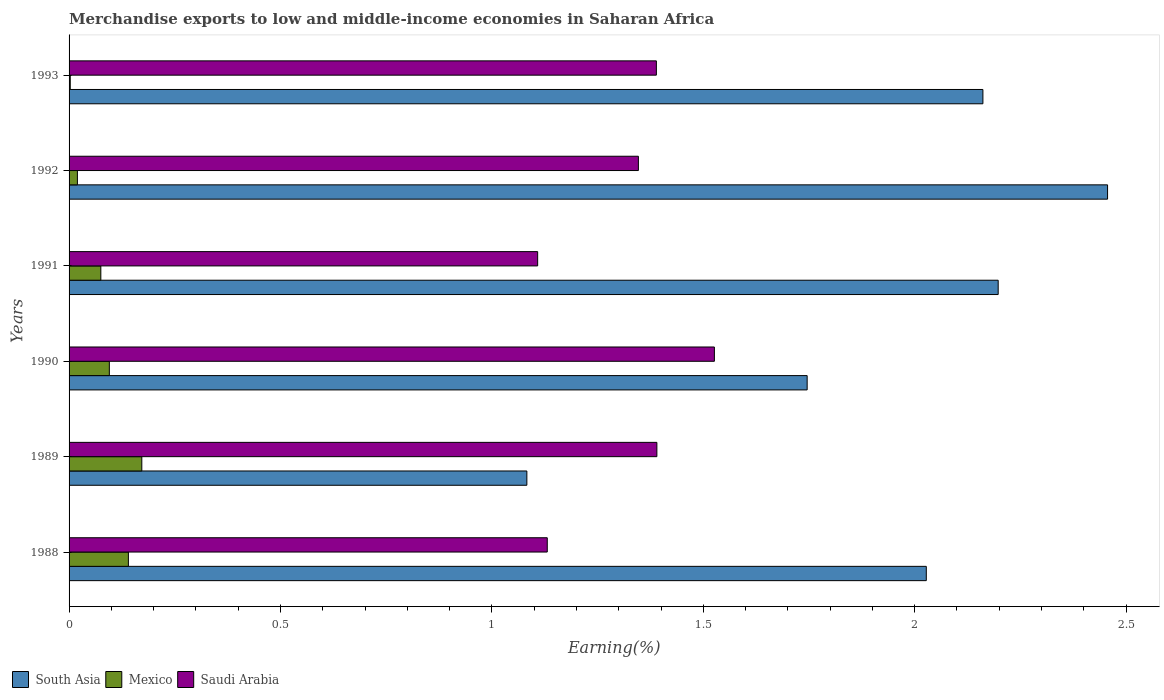How many different coloured bars are there?
Your response must be concise. 3. How many groups of bars are there?
Provide a short and direct response. 6. What is the label of the 3rd group of bars from the top?
Give a very brief answer. 1991. In how many cases, is the number of bars for a given year not equal to the number of legend labels?
Your answer should be very brief. 0. What is the percentage of amount earned from merchandise exports in Saudi Arabia in 1989?
Offer a very short reply. 1.39. Across all years, what is the maximum percentage of amount earned from merchandise exports in Mexico?
Provide a short and direct response. 0.17. Across all years, what is the minimum percentage of amount earned from merchandise exports in South Asia?
Your response must be concise. 1.08. What is the total percentage of amount earned from merchandise exports in Mexico in the graph?
Ensure brevity in your answer.  0.51. What is the difference between the percentage of amount earned from merchandise exports in South Asia in 1988 and that in 1991?
Your response must be concise. -0.17. What is the difference between the percentage of amount earned from merchandise exports in Saudi Arabia in 1993 and the percentage of amount earned from merchandise exports in Mexico in 1988?
Your answer should be compact. 1.25. What is the average percentage of amount earned from merchandise exports in South Asia per year?
Ensure brevity in your answer.  1.95. In the year 1990, what is the difference between the percentage of amount earned from merchandise exports in Mexico and percentage of amount earned from merchandise exports in Saudi Arabia?
Your answer should be compact. -1.43. In how many years, is the percentage of amount earned from merchandise exports in Saudi Arabia greater than 2.2 %?
Provide a short and direct response. 0. What is the ratio of the percentage of amount earned from merchandise exports in South Asia in 1990 to that in 1993?
Offer a terse response. 0.81. Is the percentage of amount earned from merchandise exports in South Asia in 1988 less than that in 1992?
Ensure brevity in your answer.  Yes. Is the difference between the percentage of amount earned from merchandise exports in Mexico in 1988 and 1989 greater than the difference between the percentage of amount earned from merchandise exports in Saudi Arabia in 1988 and 1989?
Offer a very short reply. Yes. What is the difference between the highest and the second highest percentage of amount earned from merchandise exports in Mexico?
Provide a succinct answer. 0.03. What is the difference between the highest and the lowest percentage of amount earned from merchandise exports in South Asia?
Provide a succinct answer. 1.37. In how many years, is the percentage of amount earned from merchandise exports in Mexico greater than the average percentage of amount earned from merchandise exports in Mexico taken over all years?
Your answer should be very brief. 3. Is the sum of the percentage of amount earned from merchandise exports in Saudi Arabia in 1989 and 1992 greater than the maximum percentage of amount earned from merchandise exports in Mexico across all years?
Make the answer very short. Yes. What does the 1st bar from the top in 1990 represents?
Your answer should be compact. Saudi Arabia. What does the 3rd bar from the bottom in 1993 represents?
Keep it short and to the point. Saudi Arabia. Is it the case that in every year, the sum of the percentage of amount earned from merchandise exports in South Asia and percentage of amount earned from merchandise exports in Saudi Arabia is greater than the percentage of amount earned from merchandise exports in Mexico?
Offer a very short reply. Yes. Are all the bars in the graph horizontal?
Offer a very short reply. Yes. Does the graph contain any zero values?
Make the answer very short. No. Where does the legend appear in the graph?
Make the answer very short. Bottom left. How many legend labels are there?
Your response must be concise. 3. How are the legend labels stacked?
Give a very brief answer. Horizontal. What is the title of the graph?
Provide a short and direct response. Merchandise exports to low and middle-income economies in Saharan Africa. Does "American Samoa" appear as one of the legend labels in the graph?
Offer a terse response. No. What is the label or title of the X-axis?
Ensure brevity in your answer.  Earning(%). What is the Earning(%) of South Asia in 1988?
Your answer should be very brief. 2.03. What is the Earning(%) in Mexico in 1988?
Provide a short and direct response. 0.14. What is the Earning(%) in Saudi Arabia in 1988?
Provide a short and direct response. 1.13. What is the Earning(%) in South Asia in 1989?
Keep it short and to the point. 1.08. What is the Earning(%) of Mexico in 1989?
Offer a terse response. 0.17. What is the Earning(%) in Saudi Arabia in 1989?
Provide a succinct answer. 1.39. What is the Earning(%) in South Asia in 1990?
Provide a short and direct response. 1.75. What is the Earning(%) of Mexico in 1990?
Your response must be concise. 0.1. What is the Earning(%) in Saudi Arabia in 1990?
Offer a very short reply. 1.53. What is the Earning(%) in South Asia in 1991?
Keep it short and to the point. 2.2. What is the Earning(%) of Mexico in 1991?
Offer a very short reply. 0.08. What is the Earning(%) of Saudi Arabia in 1991?
Provide a succinct answer. 1.11. What is the Earning(%) in South Asia in 1992?
Offer a very short reply. 2.46. What is the Earning(%) of Mexico in 1992?
Offer a terse response. 0.02. What is the Earning(%) in Saudi Arabia in 1992?
Your answer should be compact. 1.35. What is the Earning(%) of South Asia in 1993?
Give a very brief answer. 2.16. What is the Earning(%) in Mexico in 1993?
Your response must be concise. 0. What is the Earning(%) in Saudi Arabia in 1993?
Your answer should be compact. 1.39. Across all years, what is the maximum Earning(%) in South Asia?
Offer a terse response. 2.46. Across all years, what is the maximum Earning(%) in Mexico?
Offer a terse response. 0.17. Across all years, what is the maximum Earning(%) in Saudi Arabia?
Provide a succinct answer. 1.53. Across all years, what is the minimum Earning(%) of South Asia?
Provide a short and direct response. 1.08. Across all years, what is the minimum Earning(%) of Mexico?
Keep it short and to the point. 0. Across all years, what is the minimum Earning(%) of Saudi Arabia?
Provide a succinct answer. 1.11. What is the total Earning(%) of South Asia in the graph?
Provide a short and direct response. 11.67. What is the total Earning(%) in Mexico in the graph?
Your answer should be very brief. 0.51. What is the total Earning(%) of Saudi Arabia in the graph?
Keep it short and to the point. 7.89. What is the difference between the Earning(%) of South Asia in 1988 and that in 1989?
Your response must be concise. 0.94. What is the difference between the Earning(%) of Mexico in 1988 and that in 1989?
Make the answer very short. -0.03. What is the difference between the Earning(%) in Saudi Arabia in 1988 and that in 1989?
Keep it short and to the point. -0.26. What is the difference between the Earning(%) of South Asia in 1988 and that in 1990?
Provide a succinct answer. 0.28. What is the difference between the Earning(%) of Mexico in 1988 and that in 1990?
Keep it short and to the point. 0.05. What is the difference between the Earning(%) of Saudi Arabia in 1988 and that in 1990?
Your response must be concise. -0.4. What is the difference between the Earning(%) of South Asia in 1988 and that in 1991?
Make the answer very short. -0.17. What is the difference between the Earning(%) of Mexico in 1988 and that in 1991?
Ensure brevity in your answer.  0.07. What is the difference between the Earning(%) in Saudi Arabia in 1988 and that in 1991?
Give a very brief answer. 0.02. What is the difference between the Earning(%) of South Asia in 1988 and that in 1992?
Provide a short and direct response. -0.43. What is the difference between the Earning(%) of Mexico in 1988 and that in 1992?
Your answer should be very brief. 0.12. What is the difference between the Earning(%) in Saudi Arabia in 1988 and that in 1992?
Offer a very short reply. -0.22. What is the difference between the Earning(%) in South Asia in 1988 and that in 1993?
Offer a very short reply. -0.13. What is the difference between the Earning(%) in Mexico in 1988 and that in 1993?
Make the answer very short. 0.14. What is the difference between the Earning(%) in Saudi Arabia in 1988 and that in 1993?
Provide a succinct answer. -0.26. What is the difference between the Earning(%) in South Asia in 1989 and that in 1990?
Make the answer very short. -0.66. What is the difference between the Earning(%) in Mexico in 1989 and that in 1990?
Make the answer very short. 0.08. What is the difference between the Earning(%) in Saudi Arabia in 1989 and that in 1990?
Your answer should be very brief. -0.14. What is the difference between the Earning(%) of South Asia in 1989 and that in 1991?
Offer a very short reply. -1.11. What is the difference between the Earning(%) of Mexico in 1989 and that in 1991?
Make the answer very short. 0.1. What is the difference between the Earning(%) of Saudi Arabia in 1989 and that in 1991?
Offer a very short reply. 0.28. What is the difference between the Earning(%) in South Asia in 1989 and that in 1992?
Your answer should be very brief. -1.37. What is the difference between the Earning(%) of Mexico in 1989 and that in 1992?
Your answer should be compact. 0.15. What is the difference between the Earning(%) in Saudi Arabia in 1989 and that in 1992?
Your answer should be compact. 0.04. What is the difference between the Earning(%) in South Asia in 1989 and that in 1993?
Offer a very short reply. -1.08. What is the difference between the Earning(%) in Mexico in 1989 and that in 1993?
Provide a succinct answer. 0.17. What is the difference between the Earning(%) of Saudi Arabia in 1989 and that in 1993?
Keep it short and to the point. 0. What is the difference between the Earning(%) of South Asia in 1990 and that in 1991?
Your answer should be compact. -0.45. What is the difference between the Earning(%) of Mexico in 1990 and that in 1991?
Offer a very short reply. 0.02. What is the difference between the Earning(%) in Saudi Arabia in 1990 and that in 1991?
Your answer should be very brief. 0.42. What is the difference between the Earning(%) of South Asia in 1990 and that in 1992?
Your answer should be compact. -0.71. What is the difference between the Earning(%) in Mexico in 1990 and that in 1992?
Keep it short and to the point. 0.08. What is the difference between the Earning(%) in Saudi Arabia in 1990 and that in 1992?
Offer a very short reply. 0.18. What is the difference between the Earning(%) of South Asia in 1990 and that in 1993?
Offer a very short reply. -0.42. What is the difference between the Earning(%) in Mexico in 1990 and that in 1993?
Your answer should be compact. 0.09. What is the difference between the Earning(%) of Saudi Arabia in 1990 and that in 1993?
Ensure brevity in your answer.  0.14. What is the difference between the Earning(%) of South Asia in 1991 and that in 1992?
Offer a terse response. -0.26. What is the difference between the Earning(%) in Mexico in 1991 and that in 1992?
Provide a short and direct response. 0.06. What is the difference between the Earning(%) in Saudi Arabia in 1991 and that in 1992?
Offer a terse response. -0.24. What is the difference between the Earning(%) of South Asia in 1991 and that in 1993?
Provide a succinct answer. 0.04. What is the difference between the Earning(%) of Mexico in 1991 and that in 1993?
Keep it short and to the point. 0.07. What is the difference between the Earning(%) of Saudi Arabia in 1991 and that in 1993?
Your response must be concise. -0.28. What is the difference between the Earning(%) of South Asia in 1992 and that in 1993?
Provide a succinct answer. 0.29. What is the difference between the Earning(%) of Mexico in 1992 and that in 1993?
Provide a short and direct response. 0.02. What is the difference between the Earning(%) in Saudi Arabia in 1992 and that in 1993?
Provide a succinct answer. -0.04. What is the difference between the Earning(%) of South Asia in 1988 and the Earning(%) of Mexico in 1989?
Offer a very short reply. 1.86. What is the difference between the Earning(%) of South Asia in 1988 and the Earning(%) of Saudi Arabia in 1989?
Provide a short and direct response. 0.64. What is the difference between the Earning(%) in Mexico in 1988 and the Earning(%) in Saudi Arabia in 1989?
Keep it short and to the point. -1.25. What is the difference between the Earning(%) in South Asia in 1988 and the Earning(%) in Mexico in 1990?
Your response must be concise. 1.93. What is the difference between the Earning(%) in South Asia in 1988 and the Earning(%) in Saudi Arabia in 1990?
Provide a succinct answer. 0.5. What is the difference between the Earning(%) in Mexico in 1988 and the Earning(%) in Saudi Arabia in 1990?
Give a very brief answer. -1.39. What is the difference between the Earning(%) in South Asia in 1988 and the Earning(%) in Mexico in 1991?
Give a very brief answer. 1.95. What is the difference between the Earning(%) in South Asia in 1988 and the Earning(%) in Saudi Arabia in 1991?
Provide a succinct answer. 0.92. What is the difference between the Earning(%) of Mexico in 1988 and the Earning(%) of Saudi Arabia in 1991?
Give a very brief answer. -0.97. What is the difference between the Earning(%) of South Asia in 1988 and the Earning(%) of Mexico in 1992?
Offer a very short reply. 2.01. What is the difference between the Earning(%) of South Asia in 1988 and the Earning(%) of Saudi Arabia in 1992?
Offer a terse response. 0.68. What is the difference between the Earning(%) of Mexico in 1988 and the Earning(%) of Saudi Arabia in 1992?
Your answer should be very brief. -1.21. What is the difference between the Earning(%) of South Asia in 1988 and the Earning(%) of Mexico in 1993?
Make the answer very short. 2.02. What is the difference between the Earning(%) of South Asia in 1988 and the Earning(%) of Saudi Arabia in 1993?
Your answer should be compact. 0.64. What is the difference between the Earning(%) in Mexico in 1988 and the Earning(%) in Saudi Arabia in 1993?
Your response must be concise. -1.25. What is the difference between the Earning(%) of South Asia in 1989 and the Earning(%) of Mexico in 1990?
Offer a terse response. 0.99. What is the difference between the Earning(%) of South Asia in 1989 and the Earning(%) of Saudi Arabia in 1990?
Offer a terse response. -0.44. What is the difference between the Earning(%) in Mexico in 1989 and the Earning(%) in Saudi Arabia in 1990?
Offer a very short reply. -1.35. What is the difference between the Earning(%) in South Asia in 1989 and the Earning(%) in Mexico in 1991?
Make the answer very short. 1.01. What is the difference between the Earning(%) of South Asia in 1989 and the Earning(%) of Saudi Arabia in 1991?
Provide a short and direct response. -0.03. What is the difference between the Earning(%) of Mexico in 1989 and the Earning(%) of Saudi Arabia in 1991?
Make the answer very short. -0.94. What is the difference between the Earning(%) in South Asia in 1989 and the Earning(%) in Mexico in 1992?
Keep it short and to the point. 1.06. What is the difference between the Earning(%) in South Asia in 1989 and the Earning(%) in Saudi Arabia in 1992?
Offer a terse response. -0.26. What is the difference between the Earning(%) of Mexico in 1989 and the Earning(%) of Saudi Arabia in 1992?
Give a very brief answer. -1.17. What is the difference between the Earning(%) in South Asia in 1989 and the Earning(%) in Mexico in 1993?
Offer a very short reply. 1.08. What is the difference between the Earning(%) in South Asia in 1989 and the Earning(%) in Saudi Arabia in 1993?
Offer a very short reply. -0.31. What is the difference between the Earning(%) of Mexico in 1989 and the Earning(%) of Saudi Arabia in 1993?
Offer a terse response. -1.22. What is the difference between the Earning(%) of South Asia in 1990 and the Earning(%) of Mexico in 1991?
Ensure brevity in your answer.  1.67. What is the difference between the Earning(%) of South Asia in 1990 and the Earning(%) of Saudi Arabia in 1991?
Provide a succinct answer. 0.64. What is the difference between the Earning(%) of Mexico in 1990 and the Earning(%) of Saudi Arabia in 1991?
Give a very brief answer. -1.01. What is the difference between the Earning(%) of South Asia in 1990 and the Earning(%) of Mexico in 1992?
Provide a succinct answer. 1.73. What is the difference between the Earning(%) in South Asia in 1990 and the Earning(%) in Saudi Arabia in 1992?
Your answer should be very brief. 0.4. What is the difference between the Earning(%) in Mexico in 1990 and the Earning(%) in Saudi Arabia in 1992?
Your answer should be very brief. -1.25. What is the difference between the Earning(%) in South Asia in 1990 and the Earning(%) in Mexico in 1993?
Your answer should be compact. 1.74. What is the difference between the Earning(%) in South Asia in 1990 and the Earning(%) in Saudi Arabia in 1993?
Offer a terse response. 0.36. What is the difference between the Earning(%) in Mexico in 1990 and the Earning(%) in Saudi Arabia in 1993?
Offer a very short reply. -1.29. What is the difference between the Earning(%) in South Asia in 1991 and the Earning(%) in Mexico in 1992?
Provide a short and direct response. 2.18. What is the difference between the Earning(%) of South Asia in 1991 and the Earning(%) of Saudi Arabia in 1992?
Provide a short and direct response. 0.85. What is the difference between the Earning(%) of Mexico in 1991 and the Earning(%) of Saudi Arabia in 1992?
Ensure brevity in your answer.  -1.27. What is the difference between the Earning(%) in South Asia in 1991 and the Earning(%) in Mexico in 1993?
Your response must be concise. 2.19. What is the difference between the Earning(%) of South Asia in 1991 and the Earning(%) of Saudi Arabia in 1993?
Give a very brief answer. 0.81. What is the difference between the Earning(%) in Mexico in 1991 and the Earning(%) in Saudi Arabia in 1993?
Offer a terse response. -1.31. What is the difference between the Earning(%) in South Asia in 1992 and the Earning(%) in Mexico in 1993?
Keep it short and to the point. 2.45. What is the difference between the Earning(%) of South Asia in 1992 and the Earning(%) of Saudi Arabia in 1993?
Offer a very short reply. 1.07. What is the difference between the Earning(%) in Mexico in 1992 and the Earning(%) in Saudi Arabia in 1993?
Your response must be concise. -1.37. What is the average Earning(%) in South Asia per year?
Ensure brevity in your answer.  1.95. What is the average Earning(%) in Mexico per year?
Make the answer very short. 0.08. What is the average Earning(%) of Saudi Arabia per year?
Provide a short and direct response. 1.32. In the year 1988, what is the difference between the Earning(%) in South Asia and Earning(%) in Mexico?
Make the answer very short. 1.89. In the year 1988, what is the difference between the Earning(%) in South Asia and Earning(%) in Saudi Arabia?
Make the answer very short. 0.9. In the year 1988, what is the difference between the Earning(%) of Mexico and Earning(%) of Saudi Arabia?
Keep it short and to the point. -0.99. In the year 1989, what is the difference between the Earning(%) of South Asia and Earning(%) of Mexico?
Offer a terse response. 0.91. In the year 1989, what is the difference between the Earning(%) of South Asia and Earning(%) of Saudi Arabia?
Offer a terse response. -0.31. In the year 1989, what is the difference between the Earning(%) in Mexico and Earning(%) in Saudi Arabia?
Ensure brevity in your answer.  -1.22. In the year 1990, what is the difference between the Earning(%) of South Asia and Earning(%) of Mexico?
Provide a succinct answer. 1.65. In the year 1990, what is the difference between the Earning(%) of South Asia and Earning(%) of Saudi Arabia?
Keep it short and to the point. 0.22. In the year 1990, what is the difference between the Earning(%) in Mexico and Earning(%) in Saudi Arabia?
Keep it short and to the point. -1.43. In the year 1991, what is the difference between the Earning(%) of South Asia and Earning(%) of Mexico?
Provide a succinct answer. 2.12. In the year 1991, what is the difference between the Earning(%) in South Asia and Earning(%) in Saudi Arabia?
Provide a short and direct response. 1.09. In the year 1991, what is the difference between the Earning(%) in Mexico and Earning(%) in Saudi Arabia?
Give a very brief answer. -1.03. In the year 1992, what is the difference between the Earning(%) in South Asia and Earning(%) in Mexico?
Your answer should be very brief. 2.44. In the year 1992, what is the difference between the Earning(%) of South Asia and Earning(%) of Saudi Arabia?
Your answer should be very brief. 1.11. In the year 1992, what is the difference between the Earning(%) of Mexico and Earning(%) of Saudi Arabia?
Offer a terse response. -1.33. In the year 1993, what is the difference between the Earning(%) in South Asia and Earning(%) in Mexico?
Ensure brevity in your answer.  2.16. In the year 1993, what is the difference between the Earning(%) of South Asia and Earning(%) of Saudi Arabia?
Your response must be concise. 0.77. In the year 1993, what is the difference between the Earning(%) of Mexico and Earning(%) of Saudi Arabia?
Give a very brief answer. -1.39. What is the ratio of the Earning(%) in South Asia in 1988 to that in 1989?
Ensure brevity in your answer.  1.87. What is the ratio of the Earning(%) in Mexico in 1988 to that in 1989?
Offer a terse response. 0.82. What is the ratio of the Earning(%) of Saudi Arabia in 1988 to that in 1989?
Your response must be concise. 0.81. What is the ratio of the Earning(%) of South Asia in 1988 to that in 1990?
Provide a succinct answer. 1.16. What is the ratio of the Earning(%) of Mexico in 1988 to that in 1990?
Provide a succinct answer. 1.47. What is the ratio of the Earning(%) of Saudi Arabia in 1988 to that in 1990?
Provide a succinct answer. 0.74. What is the ratio of the Earning(%) of South Asia in 1988 to that in 1991?
Provide a succinct answer. 0.92. What is the ratio of the Earning(%) in Mexico in 1988 to that in 1991?
Keep it short and to the point. 1.87. What is the ratio of the Earning(%) in Saudi Arabia in 1988 to that in 1991?
Provide a succinct answer. 1.02. What is the ratio of the Earning(%) in South Asia in 1988 to that in 1992?
Make the answer very short. 0.83. What is the ratio of the Earning(%) in Mexico in 1988 to that in 1992?
Offer a terse response. 7.11. What is the ratio of the Earning(%) in Saudi Arabia in 1988 to that in 1992?
Keep it short and to the point. 0.84. What is the ratio of the Earning(%) in South Asia in 1988 to that in 1993?
Ensure brevity in your answer.  0.94. What is the ratio of the Earning(%) of Mexico in 1988 to that in 1993?
Make the answer very short. 49.98. What is the ratio of the Earning(%) in Saudi Arabia in 1988 to that in 1993?
Your answer should be very brief. 0.81. What is the ratio of the Earning(%) in South Asia in 1989 to that in 1990?
Keep it short and to the point. 0.62. What is the ratio of the Earning(%) in Mexico in 1989 to that in 1990?
Give a very brief answer. 1.81. What is the ratio of the Earning(%) of Saudi Arabia in 1989 to that in 1990?
Give a very brief answer. 0.91. What is the ratio of the Earning(%) in South Asia in 1989 to that in 1991?
Keep it short and to the point. 0.49. What is the ratio of the Earning(%) of Mexico in 1989 to that in 1991?
Offer a terse response. 2.29. What is the ratio of the Earning(%) of Saudi Arabia in 1989 to that in 1991?
Offer a terse response. 1.25. What is the ratio of the Earning(%) of South Asia in 1989 to that in 1992?
Your answer should be compact. 0.44. What is the ratio of the Earning(%) of Mexico in 1989 to that in 1992?
Your answer should be very brief. 8.72. What is the ratio of the Earning(%) in Saudi Arabia in 1989 to that in 1992?
Make the answer very short. 1.03. What is the ratio of the Earning(%) in South Asia in 1989 to that in 1993?
Keep it short and to the point. 0.5. What is the ratio of the Earning(%) in Mexico in 1989 to that in 1993?
Offer a very short reply. 61.29. What is the ratio of the Earning(%) of Saudi Arabia in 1989 to that in 1993?
Your answer should be compact. 1. What is the ratio of the Earning(%) in South Asia in 1990 to that in 1991?
Provide a succinct answer. 0.79. What is the ratio of the Earning(%) of Mexico in 1990 to that in 1991?
Offer a terse response. 1.27. What is the ratio of the Earning(%) of Saudi Arabia in 1990 to that in 1991?
Your answer should be very brief. 1.38. What is the ratio of the Earning(%) in South Asia in 1990 to that in 1992?
Give a very brief answer. 0.71. What is the ratio of the Earning(%) in Mexico in 1990 to that in 1992?
Keep it short and to the point. 4.83. What is the ratio of the Earning(%) of Saudi Arabia in 1990 to that in 1992?
Your answer should be compact. 1.13. What is the ratio of the Earning(%) in South Asia in 1990 to that in 1993?
Your response must be concise. 0.81. What is the ratio of the Earning(%) in Mexico in 1990 to that in 1993?
Your answer should be very brief. 33.93. What is the ratio of the Earning(%) in Saudi Arabia in 1990 to that in 1993?
Your response must be concise. 1.1. What is the ratio of the Earning(%) in South Asia in 1991 to that in 1992?
Provide a succinct answer. 0.89. What is the ratio of the Earning(%) in Mexico in 1991 to that in 1992?
Make the answer very short. 3.81. What is the ratio of the Earning(%) of Saudi Arabia in 1991 to that in 1992?
Give a very brief answer. 0.82. What is the ratio of the Earning(%) of South Asia in 1991 to that in 1993?
Offer a terse response. 1.02. What is the ratio of the Earning(%) of Mexico in 1991 to that in 1993?
Ensure brevity in your answer.  26.75. What is the ratio of the Earning(%) of Saudi Arabia in 1991 to that in 1993?
Provide a succinct answer. 0.8. What is the ratio of the Earning(%) in South Asia in 1992 to that in 1993?
Keep it short and to the point. 1.14. What is the ratio of the Earning(%) of Mexico in 1992 to that in 1993?
Keep it short and to the point. 7.03. What is the ratio of the Earning(%) of Saudi Arabia in 1992 to that in 1993?
Offer a terse response. 0.97. What is the difference between the highest and the second highest Earning(%) in South Asia?
Make the answer very short. 0.26. What is the difference between the highest and the second highest Earning(%) of Mexico?
Make the answer very short. 0.03. What is the difference between the highest and the second highest Earning(%) in Saudi Arabia?
Your answer should be compact. 0.14. What is the difference between the highest and the lowest Earning(%) of South Asia?
Your answer should be very brief. 1.37. What is the difference between the highest and the lowest Earning(%) in Mexico?
Offer a very short reply. 0.17. What is the difference between the highest and the lowest Earning(%) in Saudi Arabia?
Provide a succinct answer. 0.42. 